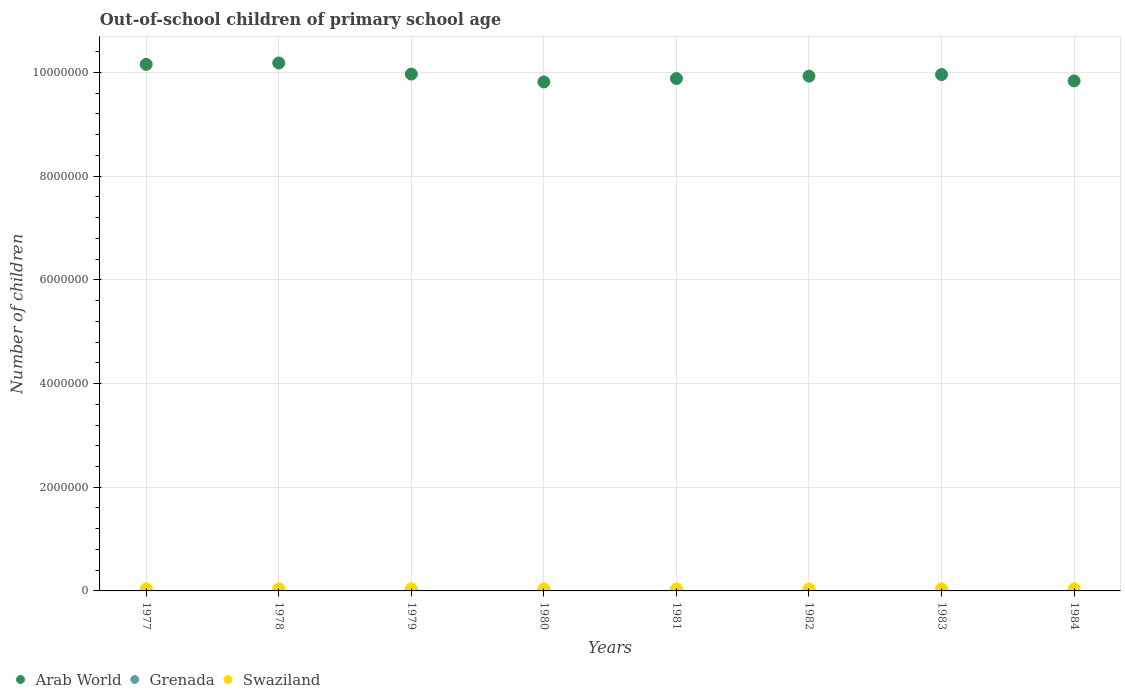How many different coloured dotlines are there?
Provide a succinct answer. 3. What is the number of out-of-school children in Swaziland in 1981?
Your answer should be compact. 3.49e+04. Across all years, what is the maximum number of out-of-school children in Grenada?
Your answer should be very brief. 1999. Across all years, what is the minimum number of out-of-school children in Grenada?
Give a very brief answer. 196. In which year was the number of out-of-school children in Arab World maximum?
Your answer should be compact. 1978. In which year was the number of out-of-school children in Grenada minimum?
Give a very brief answer. 1978. What is the total number of out-of-school children in Grenada in the graph?
Your answer should be compact. 8568. What is the difference between the number of out-of-school children in Grenada in 1977 and that in 1980?
Ensure brevity in your answer.  -281. What is the difference between the number of out-of-school children in Swaziland in 1984 and the number of out-of-school children in Grenada in 1982?
Keep it short and to the point. 3.68e+04. What is the average number of out-of-school children in Grenada per year?
Make the answer very short. 1071. In the year 1982, what is the difference between the number of out-of-school children in Grenada and number of out-of-school children in Arab World?
Give a very brief answer. -9.93e+06. What is the ratio of the number of out-of-school children in Swaziland in 1977 to that in 1984?
Ensure brevity in your answer.  0.97. What is the difference between the highest and the second highest number of out-of-school children in Grenada?
Your response must be concise. 7. What is the difference between the highest and the lowest number of out-of-school children in Grenada?
Give a very brief answer. 1803. Is the sum of the number of out-of-school children in Grenada in 1983 and 1984 greater than the maximum number of out-of-school children in Swaziland across all years?
Give a very brief answer. No. Is it the case that in every year, the sum of the number of out-of-school children in Swaziland and number of out-of-school children in Arab World  is greater than the number of out-of-school children in Grenada?
Provide a succinct answer. Yes. Is the number of out-of-school children in Swaziland strictly less than the number of out-of-school children in Grenada over the years?
Provide a short and direct response. No. How many dotlines are there?
Offer a very short reply. 3. What is the difference between two consecutive major ticks on the Y-axis?
Your answer should be very brief. 2.00e+06. Are the values on the major ticks of Y-axis written in scientific E-notation?
Give a very brief answer. No. Does the graph contain any zero values?
Your answer should be compact. No. Does the graph contain grids?
Provide a short and direct response. Yes. How many legend labels are there?
Offer a terse response. 3. How are the legend labels stacked?
Your answer should be compact. Horizontal. What is the title of the graph?
Provide a short and direct response. Out-of-school children of primary school age. What is the label or title of the X-axis?
Offer a terse response. Years. What is the label or title of the Y-axis?
Provide a short and direct response. Number of children. What is the Number of children in Arab World in 1977?
Your answer should be compact. 1.02e+07. What is the Number of children of Grenada in 1977?
Ensure brevity in your answer.  397. What is the Number of children of Swaziland in 1977?
Offer a terse response. 3.78e+04. What is the Number of children of Arab World in 1978?
Give a very brief answer. 1.02e+07. What is the Number of children in Grenada in 1978?
Your answer should be compact. 196. What is the Number of children of Swaziland in 1978?
Keep it short and to the point. 3.88e+04. What is the Number of children of Arab World in 1979?
Give a very brief answer. 9.97e+06. What is the Number of children in Grenada in 1979?
Make the answer very short. 246. What is the Number of children in Swaziland in 1979?
Provide a short and direct response. 3.90e+04. What is the Number of children in Arab World in 1980?
Your response must be concise. 9.82e+06. What is the Number of children of Grenada in 1980?
Keep it short and to the point. 678. What is the Number of children of Swaziland in 1980?
Offer a terse response. 3.76e+04. What is the Number of children in Arab World in 1981?
Your answer should be compact. 9.88e+06. What is the Number of children in Grenada in 1981?
Your answer should be compact. 1482. What is the Number of children of Swaziland in 1981?
Make the answer very short. 3.49e+04. What is the Number of children of Arab World in 1982?
Make the answer very short. 9.93e+06. What is the Number of children of Grenada in 1982?
Provide a short and direct response. 1999. What is the Number of children in Swaziland in 1982?
Your response must be concise. 3.60e+04. What is the Number of children in Arab World in 1983?
Give a very brief answer. 9.96e+06. What is the Number of children of Grenada in 1983?
Offer a terse response. 1992. What is the Number of children of Swaziland in 1983?
Your response must be concise. 3.83e+04. What is the Number of children in Arab World in 1984?
Your answer should be very brief. 9.84e+06. What is the Number of children in Grenada in 1984?
Offer a terse response. 1578. What is the Number of children in Swaziland in 1984?
Provide a succinct answer. 3.88e+04. Across all years, what is the maximum Number of children in Arab World?
Your answer should be very brief. 1.02e+07. Across all years, what is the maximum Number of children in Grenada?
Provide a short and direct response. 1999. Across all years, what is the maximum Number of children of Swaziland?
Keep it short and to the point. 3.90e+04. Across all years, what is the minimum Number of children of Arab World?
Make the answer very short. 9.82e+06. Across all years, what is the minimum Number of children of Grenada?
Offer a very short reply. 196. Across all years, what is the minimum Number of children of Swaziland?
Your answer should be compact. 3.49e+04. What is the total Number of children of Arab World in the graph?
Provide a short and direct response. 7.97e+07. What is the total Number of children of Grenada in the graph?
Your answer should be very brief. 8568. What is the total Number of children of Swaziland in the graph?
Provide a short and direct response. 3.01e+05. What is the difference between the Number of children of Arab World in 1977 and that in 1978?
Keep it short and to the point. -2.72e+04. What is the difference between the Number of children in Grenada in 1977 and that in 1978?
Give a very brief answer. 201. What is the difference between the Number of children in Swaziland in 1977 and that in 1978?
Provide a succinct answer. -953. What is the difference between the Number of children in Arab World in 1977 and that in 1979?
Your answer should be compact. 1.87e+05. What is the difference between the Number of children in Grenada in 1977 and that in 1979?
Offer a terse response. 151. What is the difference between the Number of children in Swaziland in 1977 and that in 1979?
Your answer should be compact. -1137. What is the difference between the Number of children in Arab World in 1977 and that in 1980?
Offer a terse response. 3.39e+05. What is the difference between the Number of children in Grenada in 1977 and that in 1980?
Provide a short and direct response. -281. What is the difference between the Number of children in Swaziland in 1977 and that in 1980?
Your response must be concise. 208. What is the difference between the Number of children in Arab World in 1977 and that in 1981?
Keep it short and to the point. 2.73e+05. What is the difference between the Number of children in Grenada in 1977 and that in 1981?
Your answer should be very brief. -1085. What is the difference between the Number of children in Swaziland in 1977 and that in 1981?
Offer a very short reply. 2899. What is the difference between the Number of children of Arab World in 1977 and that in 1982?
Your response must be concise. 2.27e+05. What is the difference between the Number of children of Grenada in 1977 and that in 1982?
Provide a short and direct response. -1602. What is the difference between the Number of children in Swaziland in 1977 and that in 1982?
Ensure brevity in your answer.  1808. What is the difference between the Number of children in Arab World in 1977 and that in 1983?
Make the answer very short. 1.96e+05. What is the difference between the Number of children of Grenada in 1977 and that in 1983?
Give a very brief answer. -1595. What is the difference between the Number of children in Swaziland in 1977 and that in 1983?
Offer a very short reply. -456. What is the difference between the Number of children of Arab World in 1977 and that in 1984?
Provide a succinct answer. 3.19e+05. What is the difference between the Number of children in Grenada in 1977 and that in 1984?
Provide a short and direct response. -1181. What is the difference between the Number of children in Swaziland in 1977 and that in 1984?
Provide a succinct answer. -1006. What is the difference between the Number of children in Arab World in 1978 and that in 1979?
Give a very brief answer. 2.14e+05. What is the difference between the Number of children of Grenada in 1978 and that in 1979?
Your response must be concise. -50. What is the difference between the Number of children in Swaziland in 1978 and that in 1979?
Your answer should be very brief. -184. What is the difference between the Number of children in Arab World in 1978 and that in 1980?
Make the answer very short. 3.66e+05. What is the difference between the Number of children of Grenada in 1978 and that in 1980?
Your answer should be compact. -482. What is the difference between the Number of children of Swaziland in 1978 and that in 1980?
Make the answer very short. 1161. What is the difference between the Number of children in Arab World in 1978 and that in 1981?
Provide a short and direct response. 3.01e+05. What is the difference between the Number of children in Grenada in 1978 and that in 1981?
Make the answer very short. -1286. What is the difference between the Number of children of Swaziland in 1978 and that in 1981?
Provide a short and direct response. 3852. What is the difference between the Number of children in Arab World in 1978 and that in 1982?
Ensure brevity in your answer.  2.54e+05. What is the difference between the Number of children of Grenada in 1978 and that in 1982?
Offer a terse response. -1803. What is the difference between the Number of children in Swaziland in 1978 and that in 1982?
Ensure brevity in your answer.  2761. What is the difference between the Number of children of Arab World in 1978 and that in 1983?
Provide a succinct answer. 2.24e+05. What is the difference between the Number of children in Grenada in 1978 and that in 1983?
Provide a succinct answer. -1796. What is the difference between the Number of children of Swaziland in 1978 and that in 1983?
Give a very brief answer. 497. What is the difference between the Number of children in Arab World in 1978 and that in 1984?
Offer a very short reply. 3.46e+05. What is the difference between the Number of children in Grenada in 1978 and that in 1984?
Give a very brief answer. -1382. What is the difference between the Number of children in Swaziland in 1978 and that in 1984?
Keep it short and to the point. -53. What is the difference between the Number of children of Arab World in 1979 and that in 1980?
Keep it short and to the point. 1.52e+05. What is the difference between the Number of children of Grenada in 1979 and that in 1980?
Give a very brief answer. -432. What is the difference between the Number of children of Swaziland in 1979 and that in 1980?
Ensure brevity in your answer.  1345. What is the difference between the Number of children in Arab World in 1979 and that in 1981?
Provide a succinct answer. 8.68e+04. What is the difference between the Number of children in Grenada in 1979 and that in 1981?
Offer a very short reply. -1236. What is the difference between the Number of children of Swaziland in 1979 and that in 1981?
Provide a short and direct response. 4036. What is the difference between the Number of children of Arab World in 1979 and that in 1982?
Ensure brevity in your answer.  4.01e+04. What is the difference between the Number of children of Grenada in 1979 and that in 1982?
Keep it short and to the point. -1753. What is the difference between the Number of children in Swaziland in 1979 and that in 1982?
Provide a succinct answer. 2945. What is the difference between the Number of children in Arab World in 1979 and that in 1983?
Provide a short and direct response. 9693. What is the difference between the Number of children of Grenada in 1979 and that in 1983?
Give a very brief answer. -1746. What is the difference between the Number of children in Swaziland in 1979 and that in 1983?
Your answer should be compact. 681. What is the difference between the Number of children of Arab World in 1979 and that in 1984?
Keep it short and to the point. 1.32e+05. What is the difference between the Number of children in Grenada in 1979 and that in 1984?
Ensure brevity in your answer.  -1332. What is the difference between the Number of children of Swaziland in 1979 and that in 1984?
Keep it short and to the point. 131. What is the difference between the Number of children in Arab World in 1980 and that in 1981?
Ensure brevity in your answer.  -6.51e+04. What is the difference between the Number of children of Grenada in 1980 and that in 1981?
Provide a succinct answer. -804. What is the difference between the Number of children of Swaziland in 1980 and that in 1981?
Your response must be concise. 2691. What is the difference between the Number of children in Arab World in 1980 and that in 1982?
Your answer should be compact. -1.12e+05. What is the difference between the Number of children of Grenada in 1980 and that in 1982?
Your answer should be very brief. -1321. What is the difference between the Number of children in Swaziland in 1980 and that in 1982?
Ensure brevity in your answer.  1600. What is the difference between the Number of children in Arab World in 1980 and that in 1983?
Provide a succinct answer. -1.42e+05. What is the difference between the Number of children in Grenada in 1980 and that in 1983?
Provide a short and direct response. -1314. What is the difference between the Number of children in Swaziland in 1980 and that in 1983?
Provide a short and direct response. -664. What is the difference between the Number of children of Arab World in 1980 and that in 1984?
Offer a terse response. -1.97e+04. What is the difference between the Number of children in Grenada in 1980 and that in 1984?
Offer a very short reply. -900. What is the difference between the Number of children in Swaziland in 1980 and that in 1984?
Your response must be concise. -1214. What is the difference between the Number of children of Arab World in 1981 and that in 1982?
Your response must be concise. -4.66e+04. What is the difference between the Number of children of Grenada in 1981 and that in 1982?
Provide a succinct answer. -517. What is the difference between the Number of children of Swaziland in 1981 and that in 1982?
Keep it short and to the point. -1091. What is the difference between the Number of children of Arab World in 1981 and that in 1983?
Offer a very short reply. -7.71e+04. What is the difference between the Number of children in Grenada in 1981 and that in 1983?
Give a very brief answer. -510. What is the difference between the Number of children of Swaziland in 1981 and that in 1983?
Provide a succinct answer. -3355. What is the difference between the Number of children of Arab World in 1981 and that in 1984?
Offer a terse response. 4.55e+04. What is the difference between the Number of children of Grenada in 1981 and that in 1984?
Your answer should be compact. -96. What is the difference between the Number of children in Swaziland in 1981 and that in 1984?
Your response must be concise. -3905. What is the difference between the Number of children in Arab World in 1982 and that in 1983?
Keep it short and to the point. -3.05e+04. What is the difference between the Number of children of Swaziland in 1982 and that in 1983?
Your answer should be compact. -2264. What is the difference between the Number of children in Arab World in 1982 and that in 1984?
Provide a short and direct response. 9.21e+04. What is the difference between the Number of children in Grenada in 1982 and that in 1984?
Give a very brief answer. 421. What is the difference between the Number of children in Swaziland in 1982 and that in 1984?
Your response must be concise. -2814. What is the difference between the Number of children in Arab World in 1983 and that in 1984?
Give a very brief answer. 1.23e+05. What is the difference between the Number of children in Grenada in 1983 and that in 1984?
Provide a short and direct response. 414. What is the difference between the Number of children in Swaziland in 1983 and that in 1984?
Your response must be concise. -550. What is the difference between the Number of children in Arab World in 1977 and the Number of children in Grenada in 1978?
Keep it short and to the point. 1.02e+07. What is the difference between the Number of children in Arab World in 1977 and the Number of children in Swaziland in 1978?
Give a very brief answer. 1.01e+07. What is the difference between the Number of children of Grenada in 1977 and the Number of children of Swaziland in 1978?
Provide a short and direct response. -3.84e+04. What is the difference between the Number of children of Arab World in 1977 and the Number of children of Grenada in 1979?
Your answer should be compact. 1.02e+07. What is the difference between the Number of children in Arab World in 1977 and the Number of children in Swaziland in 1979?
Your answer should be very brief. 1.01e+07. What is the difference between the Number of children of Grenada in 1977 and the Number of children of Swaziland in 1979?
Your response must be concise. -3.86e+04. What is the difference between the Number of children of Arab World in 1977 and the Number of children of Grenada in 1980?
Your response must be concise. 1.02e+07. What is the difference between the Number of children of Arab World in 1977 and the Number of children of Swaziland in 1980?
Provide a succinct answer. 1.01e+07. What is the difference between the Number of children of Grenada in 1977 and the Number of children of Swaziland in 1980?
Keep it short and to the point. -3.72e+04. What is the difference between the Number of children of Arab World in 1977 and the Number of children of Grenada in 1981?
Make the answer very short. 1.02e+07. What is the difference between the Number of children of Arab World in 1977 and the Number of children of Swaziland in 1981?
Give a very brief answer. 1.01e+07. What is the difference between the Number of children in Grenada in 1977 and the Number of children in Swaziland in 1981?
Ensure brevity in your answer.  -3.45e+04. What is the difference between the Number of children of Arab World in 1977 and the Number of children of Grenada in 1982?
Offer a very short reply. 1.02e+07. What is the difference between the Number of children of Arab World in 1977 and the Number of children of Swaziland in 1982?
Offer a very short reply. 1.01e+07. What is the difference between the Number of children of Grenada in 1977 and the Number of children of Swaziland in 1982?
Provide a succinct answer. -3.56e+04. What is the difference between the Number of children in Arab World in 1977 and the Number of children in Grenada in 1983?
Provide a succinct answer. 1.02e+07. What is the difference between the Number of children in Arab World in 1977 and the Number of children in Swaziland in 1983?
Offer a terse response. 1.01e+07. What is the difference between the Number of children of Grenada in 1977 and the Number of children of Swaziland in 1983?
Offer a very short reply. -3.79e+04. What is the difference between the Number of children in Arab World in 1977 and the Number of children in Grenada in 1984?
Give a very brief answer. 1.02e+07. What is the difference between the Number of children in Arab World in 1977 and the Number of children in Swaziland in 1984?
Provide a short and direct response. 1.01e+07. What is the difference between the Number of children of Grenada in 1977 and the Number of children of Swaziland in 1984?
Provide a short and direct response. -3.84e+04. What is the difference between the Number of children of Arab World in 1978 and the Number of children of Grenada in 1979?
Give a very brief answer. 1.02e+07. What is the difference between the Number of children of Arab World in 1978 and the Number of children of Swaziland in 1979?
Provide a succinct answer. 1.01e+07. What is the difference between the Number of children in Grenada in 1978 and the Number of children in Swaziland in 1979?
Offer a terse response. -3.88e+04. What is the difference between the Number of children of Arab World in 1978 and the Number of children of Grenada in 1980?
Offer a terse response. 1.02e+07. What is the difference between the Number of children in Arab World in 1978 and the Number of children in Swaziland in 1980?
Provide a succinct answer. 1.01e+07. What is the difference between the Number of children in Grenada in 1978 and the Number of children in Swaziland in 1980?
Make the answer very short. -3.74e+04. What is the difference between the Number of children of Arab World in 1978 and the Number of children of Grenada in 1981?
Offer a terse response. 1.02e+07. What is the difference between the Number of children of Arab World in 1978 and the Number of children of Swaziland in 1981?
Provide a succinct answer. 1.01e+07. What is the difference between the Number of children in Grenada in 1978 and the Number of children in Swaziland in 1981?
Offer a very short reply. -3.47e+04. What is the difference between the Number of children of Arab World in 1978 and the Number of children of Grenada in 1982?
Offer a very short reply. 1.02e+07. What is the difference between the Number of children in Arab World in 1978 and the Number of children in Swaziland in 1982?
Keep it short and to the point. 1.01e+07. What is the difference between the Number of children in Grenada in 1978 and the Number of children in Swaziland in 1982?
Your answer should be compact. -3.58e+04. What is the difference between the Number of children in Arab World in 1978 and the Number of children in Grenada in 1983?
Give a very brief answer. 1.02e+07. What is the difference between the Number of children in Arab World in 1978 and the Number of children in Swaziland in 1983?
Ensure brevity in your answer.  1.01e+07. What is the difference between the Number of children in Grenada in 1978 and the Number of children in Swaziland in 1983?
Offer a very short reply. -3.81e+04. What is the difference between the Number of children in Arab World in 1978 and the Number of children in Grenada in 1984?
Your response must be concise. 1.02e+07. What is the difference between the Number of children of Arab World in 1978 and the Number of children of Swaziland in 1984?
Give a very brief answer. 1.01e+07. What is the difference between the Number of children of Grenada in 1978 and the Number of children of Swaziland in 1984?
Offer a very short reply. -3.86e+04. What is the difference between the Number of children of Arab World in 1979 and the Number of children of Grenada in 1980?
Provide a short and direct response. 9.97e+06. What is the difference between the Number of children in Arab World in 1979 and the Number of children in Swaziland in 1980?
Offer a terse response. 9.93e+06. What is the difference between the Number of children in Grenada in 1979 and the Number of children in Swaziland in 1980?
Your response must be concise. -3.74e+04. What is the difference between the Number of children of Arab World in 1979 and the Number of children of Grenada in 1981?
Offer a very short reply. 9.97e+06. What is the difference between the Number of children of Arab World in 1979 and the Number of children of Swaziland in 1981?
Provide a short and direct response. 9.93e+06. What is the difference between the Number of children of Grenada in 1979 and the Number of children of Swaziland in 1981?
Offer a very short reply. -3.47e+04. What is the difference between the Number of children in Arab World in 1979 and the Number of children in Grenada in 1982?
Offer a very short reply. 9.97e+06. What is the difference between the Number of children of Arab World in 1979 and the Number of children of Swaziland in 1982?
Offer a terse response. 9.93e+06. What is the difference between the Number of children of Grenada in 1979 and the Number of children of Swaziland in 1982?
Your answer should be very brief. -3.58e+04. What is the difference between the Number of children in Arab World in 1979 and the Number of children in Grenada in 1983?
Offer a terse response. 9.97e+06. What is the difference between the Number of children in Arab World in 1979 and the Number of children in Swaziland in 1983?
Your response must be concise. 9.93e+06. What is the difference between the Number of children of Grenada in 1979 and the Number of children of Swaziland in 1983?
Offer a terse response. -3.80e+04. What is the difference between the Number of children of Arab World in 1979 and the Number of children of Grenada in 1984?
Provide a succinct answer. 9.97e+06. What is the difference between the Number of children in Arab World in 1979 and the Number of children in Swaziland in 1984?
Your answer should be very brief. 9.93e+06. What is the difference between the Number of children in Grenada in 1979 and the Number of children in Swaziland in 1984?
Offer a terse response. -3.86e+04. What is the difference between the Number of children of Arab World in 1980 and the Number of children of Grenada in 1981?
Your answer should be compact. 9.82e+06. What is the difference between the Number of children of Arab World in 1980 and the Number of children of Swaziland in 1981?
Give a very brief answer. 9.78e+06. What is the difference between the Number of children of Grenada in 1980 and the Number of children of Swaziland in 1981?
Your response must be concise. -3.42e+04. What is the difference between the Number of children in Arab World in 1980 and the Number of children in Grenada in 1982?
Your answer should be very brief. 9.82e+06. What is the difference between the Number of children of Arab World in 1980 and the Number of children of Swaziland in 1982?
Your answer should be very brief. 9.78e+06. What is the difference between the Number of children in Grenada in 1980 and the Number of children in Swaziland in 1982?
Offer a terse response. -3.53e+04. What is the difference between the Number of children in Arab World in 1980 and the Number of children in Grenada in 1983?
Ensure brevity in your answer.  9.82e+06. What is the difference between the Number of children of Arab World in 1980 and the Number of children of Swaziland in 1983?
Give a very brief answer. 9.78e+06. What is the difference between the Number of children of Grenada in 1980 and the Number of children of Swaziland in 1983?
Give a very brief answer. -3.76e+04. What is the difference between the Number of children in Arab World in 1980 and the Number of children in Grenada in 1984?
Your answer should be very brief. 9.82e+06. What is the difference between the Number of children in Arab World in 1980 and the Number of children in Swaziland in 1984?
Provide a short and direct response. 9.78e+06. What is the difference between the Number of children of Grenada in 1980 and the Number of children of Swaziland in 1984?
Your response must be concise. -3.81e+04. What is the difference between the Number of children in Arab World in 1981 and the Number of children in Grenada in 1982?
Your answer should be very brief. 9.88e+06. What is the difference between the Number of children in Arab World in 1981 and the Number of children in Swaziland in 1982?
Ensure brevity in your answer.  9.85e+06. What is the difference between the Number of children of Grenada in 1981 and the Number of children of Swaziland in 1982?
Offer a very short reply. -3.45e+04. What is the difference between the Number of children in Arab World in 1981 and the Number of children in Grenada in 1983?
Offer a very short reply. 9.88e+06. What is the difference between the Number of children of Arab World in 1981 and the Number of children of Swaziland in 1983?
Provide a succinct answer. 9.84e+06. What is the difference between the Number of children of Grenada in 1981 and the Number of children of Swaziland in 1983?
Offer a very short reply. -3.68e+04. What is the difference between the Number of children in Arab World in 1981 and the Number of children in Grenada in 1984?
Keep it short and to the point. 9.88e+06. What is the difference between the Number of children of Arab World in 1981 and the Number of children of Swaziland in 1984?
Provide a succinct answer. 9.84e+06. What is the difference between the Number of children in Grenada in 1981 and the Number of children in Swaziland in 1984?
Provide a succinct answer. -3.73e+04. What is the difference between the Number of children of Arab World in 1982 and the Number of children of Grenada in 1983?
Offer a very short reply. 9.93e+06. What is the difference between the Number of children in Arab World in 1982 and the Number of children in Swaziland in 1983?
Make the answer very short. 9.89e+06. What is the difference between the Number of children in Grenada in 1982 and the Number of children in Swaziland in 1983?
Provide a short and direct response. -3.63e+04. What is the difference between the Number of children in Arab World in 1982 and the Number of children in Grenada in 1984?
Provide a short and direct response. 9.93e+06. What is the difference between the Number of children of Arab World in 1982 and the Number of children of Swaziland in 1984?
Make the answer very short. 9.89e+06. What is the difference between the Number of children of Grenada in 1982 and the Number of children of Swaziland in 1984?
Keep it short and to the point. -3.68e+04. What is the difference between the Number of children in Arab World in 1983 and the Number of children in Grenada in 1984?
Make the answer very short. 9.96e+06. What is the difference between the Number of children in Arab World in 1983 and the Number of children in Swaziland in 1984?
Offer a very short reply. 9.92e+06. What is the difference between the Number of children of Grenada in 1983 and the Number of children of Swaziland in 1984?
Offer a terse response. -3.68e+04. What is the average Number of children in Arab World per year?
Make the answer very short. 9.97e+06. What is the average Number of children in Grenada per year?
Keep it short and to the point. 1071. What is the average Number of children of Swaziland per year?
Offer a terse response. 3.76e+04. In the year 1977, what is the difference between the Number of children of Arab World and Number of children of Grenada?
Your answer should be very brief. 1.02e+07. In the year 1977, what is the difference between the Number of children of Arab World and Number of children of Swaziland?
Give a very brief answer. 1.01e+07. In the year 1977, what is the difference between the Number of children of Grenada and Number of children of Swaziland?
Keep it short and to the point. -3.74e+04. In the year 1978, what is the difference between the Number of children in Arab World and Number of children in Grenada?
Make the answer very short. 1.02e+07. In the year 1978, what is the difference between the Number of children in Arab World and Number of children in Swaziland?
Provide a short and direct response. 1.01e+07. In the year 1978, what is the difference between the Number of children of Grenada and Number of children of Swaziland?
Offer a very short reply. -3.86e+04. In the year 1979, what is the difference between the Number of children in Arab World and Number of children in Grenada?
Your answer should be very brief. 9.97e+06. In the year 1979, what is the difference between the Number of children of Arab World and Number of children of Swaziland?
Provide a short and direct response. 9.93e+06. In the year 1979, what is the difference between the Number of children of Grenada and Number of children of Swaziland?
Provide a short and direct response. -3.87e+04. In the year 1980, what is the difference between the Number of children of Arab World and Number of children of Grenada?
Keep it short and to the point. 9.82e+06. In the year 1980, what is the difference between the Number of children in Arab World and Number of children in Swaziland?
Your answer should be very brief. 9.78e+06. In the year 1980, what is the difference between the Number of children of Grenada and Number of children of Swaziland?
Ensure brevity in your answer.  -3.69e+04. In the year 1981, what is the difference between the Number of children in Arab World and Number of children in Grenada?
Make the answer very short. 9.88e+06. In the year 1981, what is the difference between the Number of children of Arab World and Number of children of Swaziland?
Provide a short and direct response. 9.85e+06. In the year 1981, what is the difference between the Number of children in Grenada and Number of children in Swaziland?
Provide a short and direct response. -3.34e+04. In the year 1982, what is the difference between the Number of children of Arab World and Number of children of Grenada?
Offer a very short reply. 9.93e+06. In the year 1982, what is the difference between the Number of children in Arab World and Number of children in Swaziland?
Offer a terse response. 9.89e+06. In the year 1982, what is the difference between the Number of children of Grenada and Number of children of Swaziland?
Provide a short and direct response. -3.40e+04. In the year 1983, what is the difference between the Number of children of Arab World and Number of children of Grenada?
Your answer should be very brief. 9.96e+06. In the year 1983, what is the difference between the Number of children in Arab World and Number of children in Swaziland?
Make the answer very short. 9.92e+06. In the year 1983, what is the difference between the Number of children in Grenada and Number of children in Swaziland?
Ensure brevity in your answer.  -3.63e+04. In the year 1984, what is the difference between the Number of children of Arab World and Number of children of Grenada?
Provide a succinct answer. 9.84e+06. In the year 1984, what is the difference between the Number of children of Arab World and Number of children of Swaziland?
Provide a succinct answer. 9.80e+06. In the year 1984, what is the difference between the Number of children of Grenada and Number of children of Swaziland?
Keep it short and to the point. -3.72e+04. What is the ratio of the Number of children of Grenada in 1977 to that in 1978?
Your answer should be very brief. 2.03. What is the ratio of the Number of children in Swaziland in 1977 to that in 1978?
Your response must be concise. 0.98. What is the ratio of the Number of children of Arab World in 1977 to that in 1979?
Offer a very short reply. 1.02. What is the ratio of the Number of children in Grenada in 1977 to that in 1979?
Your response must be concise. 1.61. What is the ratio of the Number of children in Swaziland in 1977 to that in 1979?
Make the answer very short. 0.97. What is the ratio of the Number of children in Arab World in 1977 to that in 1980?
Your answer should be compact. 1.03. What is the ratio of the Number of children of Grenada in 1977 to that in 1980?
Offer a very short reply. 0.59. What is the ratio of the Number of children of Swaziland in 1977 to that in 1980?
Your answer should be compact. 1.01. What is the ratio of the Number of children of Arab World in 1977 to that in 1981?
Your response must be concise. 1.03. What is the ratio of the Number of children of Grenada in 1977 to that in 1981?
Provide a succinct answer. 0.27. What is the ratio of the Number of children in Swaziland in 1977 to that in 1981?
Your response must be concise. 1.08. What is the ratio of the Number of children in Arab World in 1977 to that in 1982?
Ensure brevity in your answer.  1.02. What is the ratio of the Number of children in Grenada in 1977 to that in 1982?
Offer a very short reply. 0.2. What is the ratio of the Number of children of Swaziland in 1977 to that in 1982?
Offer a terse response. 1.05. What is the ratio of the Number of children of Arab World in 1977 to that in 1983?
Your answer should be very brief. 1.02. What is the ratio of the Number of children of Grenada in 1977 to that in 1983?
Provide a short and direct response. 0.2. What is the ratio of the Number of children in Arab World in 1977 to that in 1984?
Your response must be concise. 1.03. What is the ratio of the Number of children of Grenada in 1977 to that in 1984?
Give a very brief answer. 0.25. What is the ratio of the Number of children in Swaziland in 1977 to that in 1984?
Your answer should be very brief. 0.97. What is the ratio of the Number of children of Arab World in 1978 to that in 1979?
Your response must be concise. 1.02. What is the ratio of the Number of children of Grenada in 1978 to that in 1979?
Offer a very short reply. 0.8. What is the ratio of the Number of children in Swaziland in 1978 to that in 1979?
Ensure brevity in your answer.  1. What is the ratio of the Number of children of Arab World in 1978 to that in 1980?
Offer a terse response. 1.04. What is the ratio of the Number of children of Grenada in 1978 to that in 1980?
Give a very brief answer. 0.29. What is the ratio of the Number of children of Swaziland in 1978 to that in 1980?
Your answer should be very brief. 1.03. What is the ratio of the Number of children in Arab World in 1978 to that in 1981?
Give a very brief answer. 1.03. What is the ratio of the Number of children of Grenada in 1978 to that in 1981?
Your answer should be very brief. 0.13. What is the ratio of the Number of children of Swaziland in 1978 to that in 1981?
Your response must be concise. 1.11. What is the ratio of the Number of children of Arab World in 1978 to that in 1982?
Give a very brief answer. 1.03. What is the ratio of the Number of children in Grenada in 1978 to that in 1982?
Keep it short and to the point. 0.1. What is the ratio of the Number of children in Swaziland in 1978 to that in 1982?
Provide a short and direct response. 1.08. What is the ratio of the Number of children in Arab World in 1978 to that in 1983?
Provide a succinct answer. 1.02. What is the ratio of the Number of children in Grenada in 1978 to that in 1983?
Keep it short and to the point. 0.1. What is the ratio of the Number of children of Swaziland in 1978 to that in 1983?
Provide a short and direct response. 1.01. What is the ratio of the Number of children in Arab World in 1978 to that in 1984?
Your answer should be very brief. 1.04. What is the ratio of the Number of children in Grenada in 1978 to that in 1984?
Your response must be concise. 0.12. What is the ratio of the Number of children in Arab World in 1979 to that in 1980?
Your response must be concise. 1.02. What is the ratio of the Number of children of Grenada in 1979 to that in 1980?
Provide a succinct answer. 0.36. What is the ratio of the Number of children of Swaziland in 1979 to that in 1980?
Offer a terse response. 1.04. What is the ratio of the Number of children in Arab World in 1979 to that in 1981?
Offer a very short reply. 1.01. What is the ratio of the Number of children of Grenada in 1979 to that in 1981?
Provide a short and direct response. 0.17. What is the ratio of the Number of children of Swaziland in 1979 to that in 1981?
Make the answer very short. 1.12. What is the ratio of the Number of children in Grenada in 1979 to that in 1982?
Your answer should be very brief. 0.12. What is the ratio of the Number of children of Swaziland in 1979 to that in 1982?
Your response must be concise. 1.08. What is the ratio of the Number of children in Arab World in 1979 to that in 1983?
Ensure brevity in your answer.  1. What is the ratio of the Number of children of Grenada in 1979 to that in 1983?
Your answer should be very brief. 0.12. What is the ratio of the Number of children of Swaziland in 1979 to that in 1983?
Offer a terse response. 1.02. What is the ratio of the Number of children in Arab World in 1979 to that in 1984?
Make the answer very short. 1.01. What is the ratio of the Number of children in Grenada in 1979 to that in 1984?
Offer a terse response. 0.16. What is the ratio of the Number of children of Swaziland in 1979 to that in 1984?
Your answer should be very brief. 1. What is the ratio of the Number of children of Grenada in 1980 to that in 1981?
Provide a succinct answer. 0.46. What is the ratio of the Number of children of Swaziland in 1980 to that in 1981?
Offer a terse response. 1.08. What is the ratio of the Number of children in Arab World in 1980 to that in 1982?
Make the answer very short. 0.99. What is the ratio of the Number of children of Grenada in 1980 to that in 1982?
Provide a succinct answer. 0.34. What is the ratio of the Number of children of Swaziland in 1980 to that in 1982?
Your response must be concise. 1.04. What is the ratio of the Number of children of Arab World in 1980 to that in 1983?
Provide a short and direct response. 0.99. What is the ratio of the Number of children in Grenada in 1980 to that in 1983?
Your answer should be compact. 0.34. What is the ratio of the Number of children in Swaziland in 1980 to that in 1983?
Give a very brief answer. 0.98. What is the ratio of the Number of children in Arab World in 1980 to that in 1984?
Provide a succinct answer. 1. What is the ratio of the Number of children of Grenada in 1980 to that in 1984?
Ensure brevity in your answer.  0.43. What is the ratio of the Number of children of Swaziland in 1980 to that in 1984?
Offer a very short reply. 0.97. What is the ratio of the Number of children of Grenada in 1981 to that in 1982?
Offer a very short reply. 0.74. What is the ratio of the Number of children in Swaziland in 1981 to that in 1982?
Keep it short and to the point. 0.97. What is the ratio of the Number of children of Grenada in 1981 to that in 1983?
Offer a terse response. 0.74. What is the ratio of the Number of children in Swaziland in 1981 to that in 1983?
Your response must be concise. 0.91. What is the ratio of the Number of children of Arab World in 1981 to that in 1984?
Provide a succinct answer. 1. What is the ratio of the Number of children in Grenada in 1981 to that in 1984?
Offer a terse response. 0.94. What is the ratio of the Number of children in Swaziland in 1981 to that in 1984?
Ensure brevity in your answer.  0.9. What is the ratio of the Number of children of Arab World in 1982 to that in 1983?
Make the answer very short. 1. What is the ratio of the Number of children of Swaziland in 1982 to that in 1983?
Give a very brief answer. 0.94. What is the ratio of the Number of children in Arab World in 1982 to that in 1984?
Provide a short and direct response. 1.01. What is the ratio of the Number of children of Grenada in 1982 to that in 1984?
Provide a short and direct response. 1.27. What is the ratio of the Number of children in Swaziland in 1982 to that in 1984?
Provide a succinct answer. 0.93. What is the ratio of the Number of children of Arab World in 1983 to that in 1984?
Your answer should be very brief. 1.01. What is the ratio of the Number of children of Grenada in 1983 to that in 1984?
Offer a terse response. 1.26. What is the ratio of the Number of children of Swaziland in 1983 to that in 1984?
Make the answer very short. 0.99. What is the difference between the highest and the second highest Number of children in Arab World?
Your answer should be very brief. 2.72e+04. What is the difference between the highest and the second highest Number of children in Swaziland?
Keep it short and to the point. 131. What is the difference between the highest and the lowest Number of children of Arab World?
Keep it short and to the point. 3.66e+05. What is the difference between the highest and the lowest Number of children of Grenada?
Make the answer very short. 1803. What is the difference between the highest and the lowest Number of children of Swaziland?
Your answer should be very brief. 4036. 